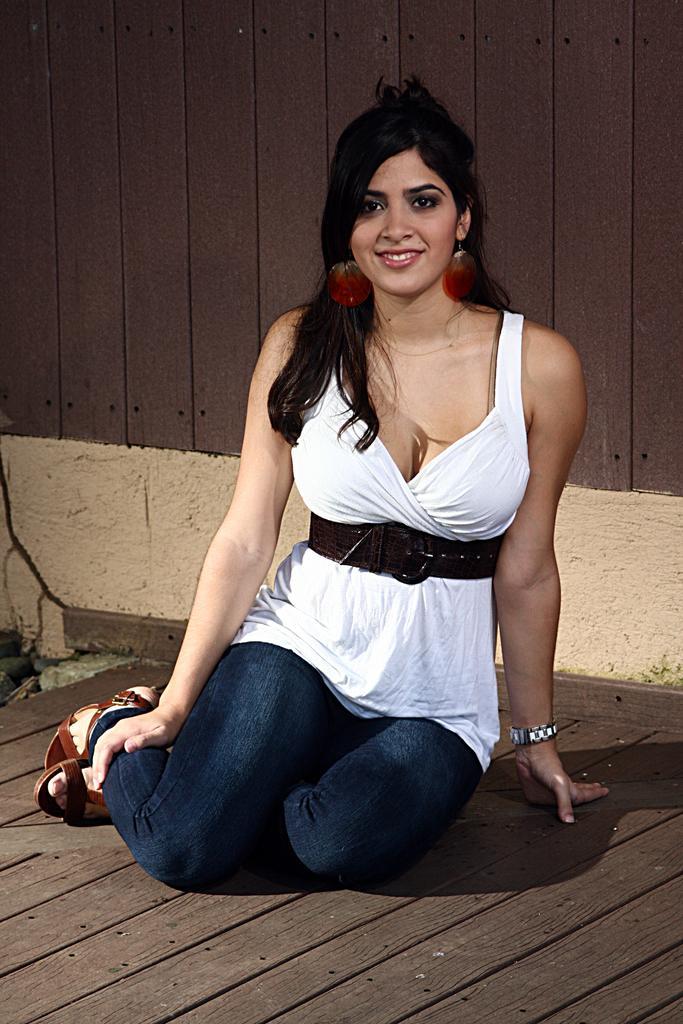How would you summarize this image in a sentence or two? In this image there is a girl sat on the wooden floor with a smile on her face, behind the girl there is a wooden wall. 